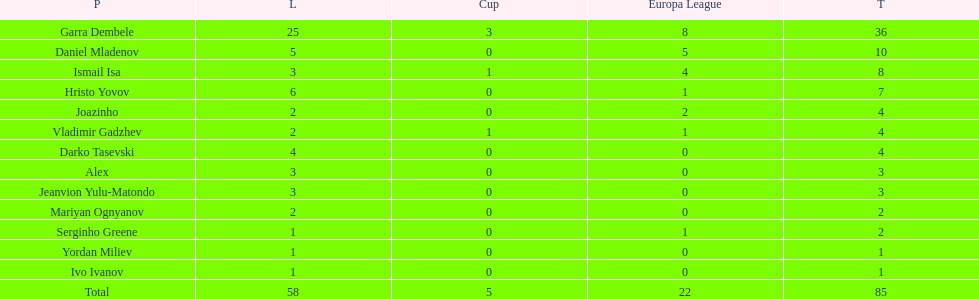How many goals did ismail isa score this season? 8. 